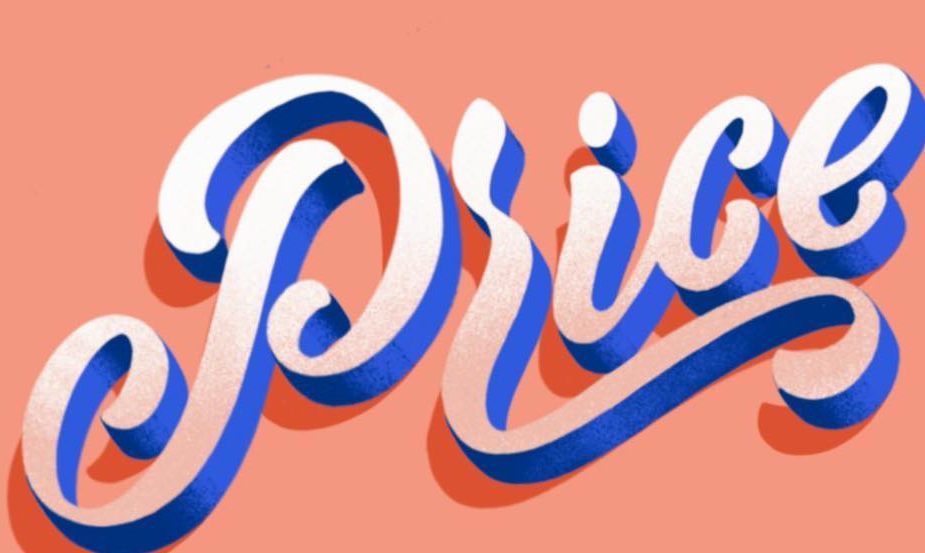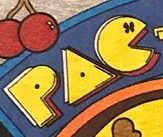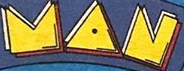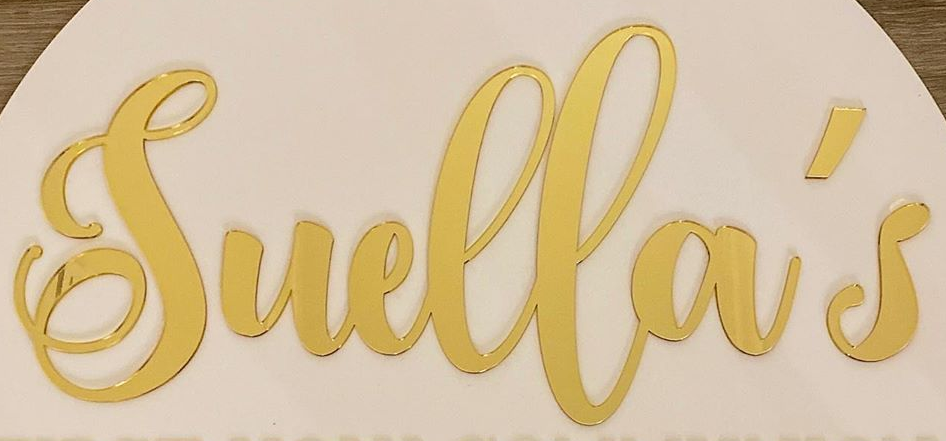Read the text content from these images in order, separated by a semicolon. Price; PAC; MAN; Suella's 